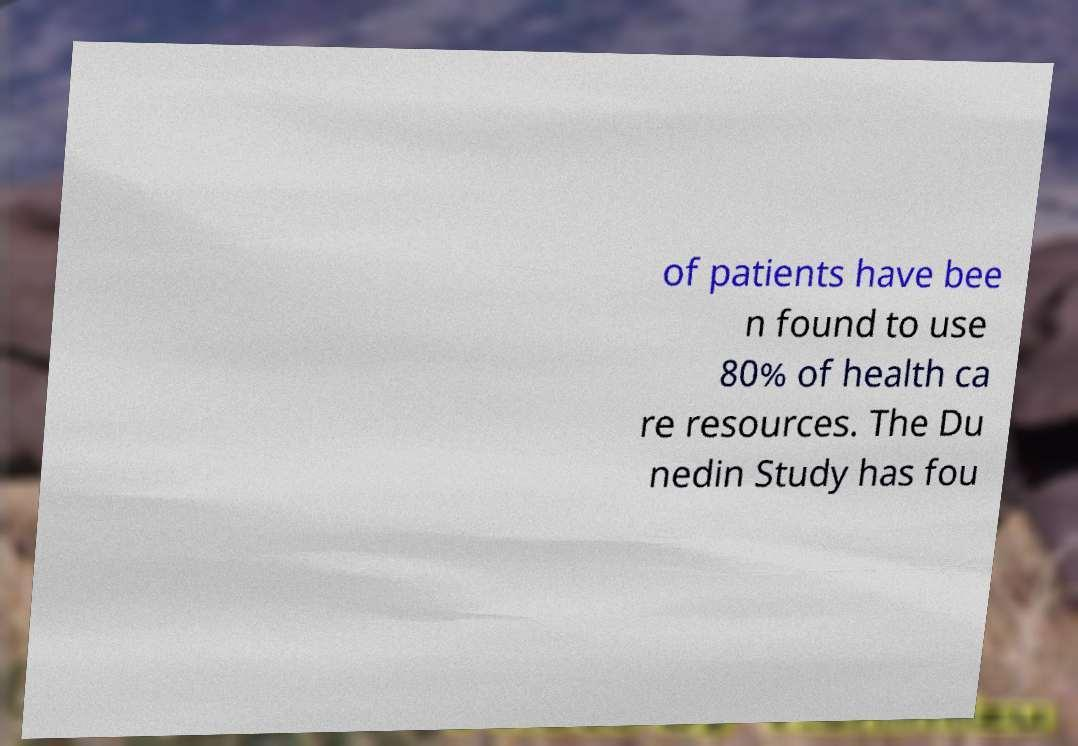Please read and relay the text visible in this image. What does it say? of patients have bee n found to use 80% of health ca re resources. The Du nedin Study has fou 